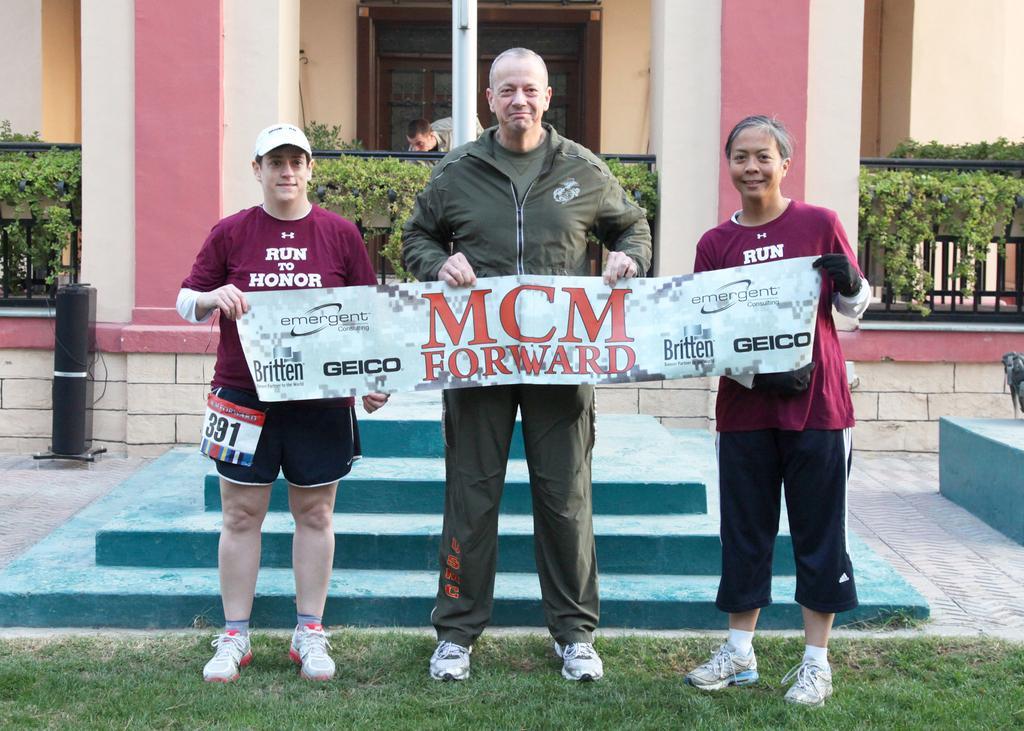In one or two sentences, can you explain what this image depicts? In the background we can see door, pillars, plants, fence and a person. Here we can see people standing holding banner with their hands. At the bottom of the picture we can see grass. 